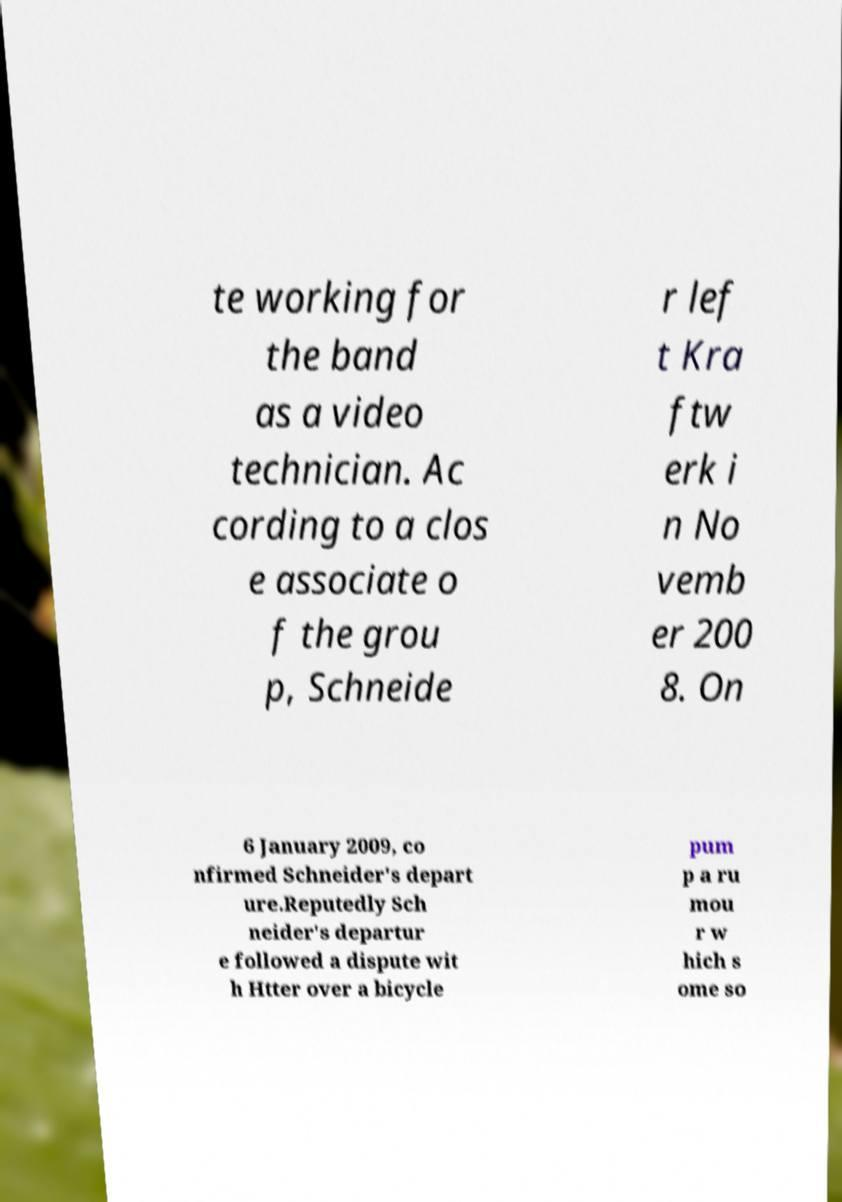There's text embedded in this image that I need extracted. Can you transcribe it verbatim? te working for the band as a video technician. Ac cording to a clos e associate o f the grou p, Schneide r lef t Kra ftw erk i n No vemb er 200 8. On 6 January 2009, co nfirmed Schneider's depart ure.Reputedly Sch neider's departur e followed a dispute wit h Htter over a bicycle pum p a ru mou r w hich s ome so 